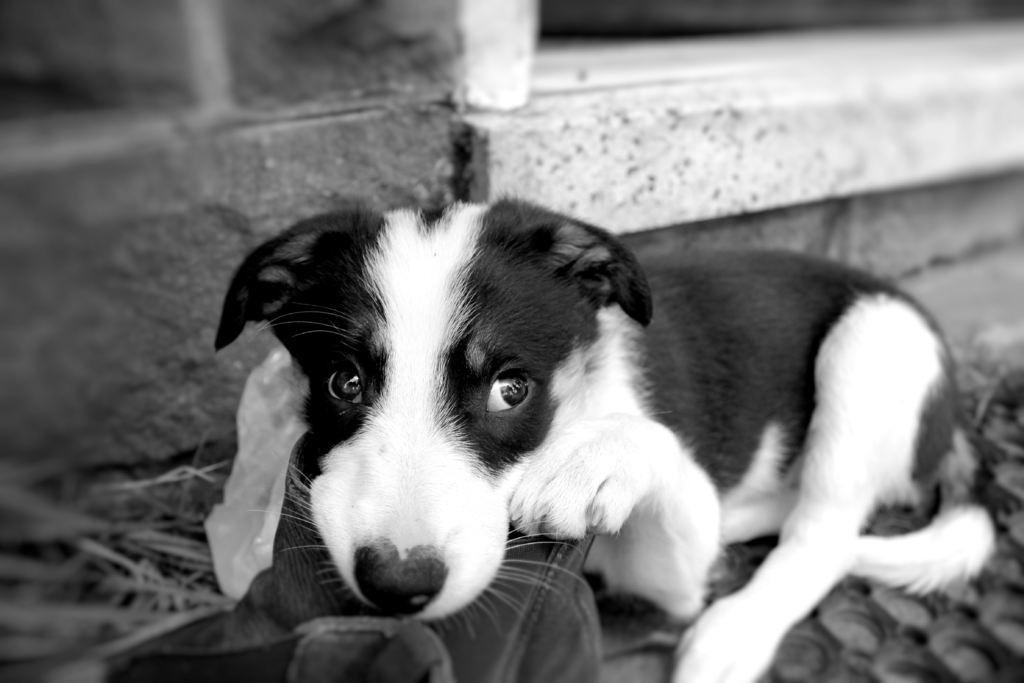What is the color scheme of the image? The image is black and white. What animal can be seen in the image? There is a puppy sitting in the image. What object is present in the image besides the puppy? There is a bag in the image. What type of structure is visible in the image? There is a wall in the image. What type of plant is growing on the wall in the image? There is no plant growing on the wall in the image; it is a black and white image with no visible plants. 